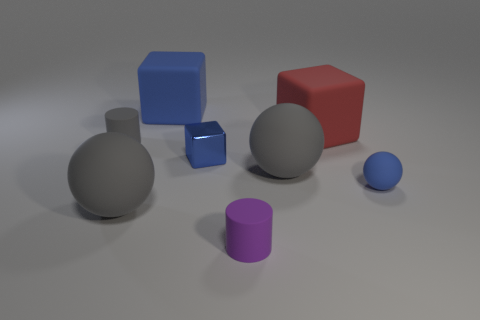Subtract all purple spheres. Subtract all red cylinders. How many spheres are left? 3 Add 1 gray spheres. How many objects exist? 9 Subtract all blocks. How many objects are left? 5 Subtract all green rubber cylinders. Subtract all large red objects. How many objects are left? 7 Add 8 cylinders. How many cylinders are left? 10 Add 8 big red rubber objects. How many big red rubber objects exist? 9 Subtract 0 yellow cylinders. How many objects are left? 8 